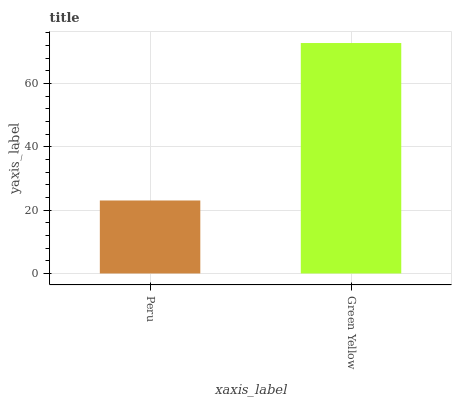Is Peru the minimum?
Answer yes or no. Yes. Is Green Yellow the maximum?
Answer yes or no. Yes. Is Green Yellow the minimum?
Answer yes or no. No. Is Green Yellow greater than Peru?
Answer yes or no. Yes. Is Peru less than Green Yellow?
Answer yes or no. Yes. Is Peru greater than Green Yellow?
Answer yes or no. No. Is Green Yellow less than Peru?
Answer yes or no. No. Is Green Yellow the high median?
Answer yes or no. Yes. Is Peru the low median?
Answer yes or no. Yes. Is Peru the high median?
Answer yes or no. No. Is Green Yellow the low median?
Answer yes or no. No. 